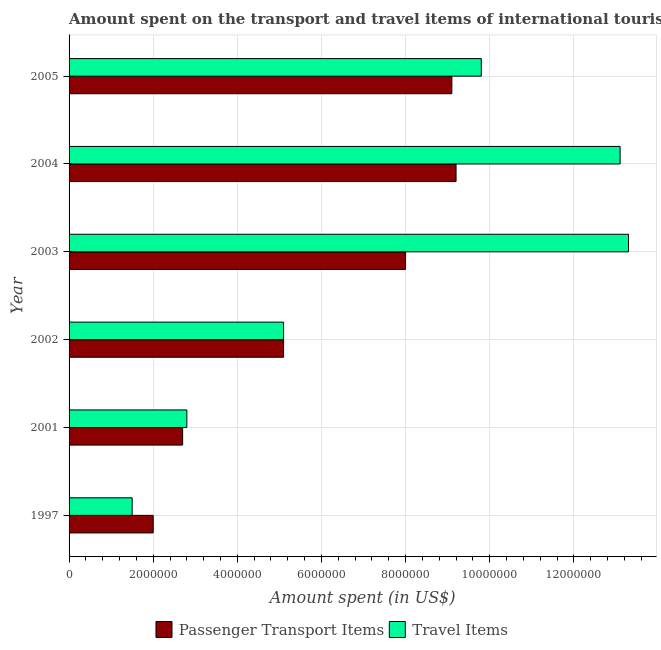How many different coloured bars are there?
Keep it short and to the point. 2. Are the number of bars per tick equal to the number of legend labels?
Offer a very short reply. Yes. How many bars are there on the 4th tick from the top?
Offer a terse response. 2. How many bars are there on the 2nd tick from the bottom?
Your answer should be compact. 2. What is the amount spent in travel items in 2005?
Give a very brief answer. 9.80e+06. Across all years, what is the maximum amount spent in travel items?
Your response must be concise. 1.33e+07. Across all years, what is the minimum amount spent in travel items?
Keep it short and to the point. 1.50e+06. In which year was the amount spent in travel items maximum?
Offer a very short reply. 2003. In which year was the amount spent in travel items minimum?
Your answer should be very brief. 1997. What is the total amount spent in travel items in the graph?
Keep it short and to the point. 4.56e+07. What is the difference between the amount spent in travel items in 1997 and that in 2003?
Provide a short and direct response. -1.18e+07. What is the difference between the amount spent on passenger transport items in 2004 and the amount spent in travel items in 2002?
Offer a very short reply. 4.10e+06. What is the average amount spent in travel items per year?
Your answer should be compact. 7.60e+06. In the year 2004, what is the difference between the amount spent on passenger transport items and amount spent in travel items?
Your answer should be compact. -3.90e+06. In how many years, is the amount spent on passenger transport items greater than 5200000 US$?
Make the answer very short. 3. What is the ratio of the amount spent in travel items in 2001 to that in 2004?
Your answer should be very brief. 0.21. Is the difference between the amount spent on passenger transport items in 2002 and 2003 greater than the difference between the amount spent in travel items in 2002 and 2003?
Your response must be concise. Yes. What is the difference between the highest and the lowest amount spent on passenger transport items?
Give a very brief answer. 7.20e+06. What does the 2nd bar from the top in 2003 represents?
Give a very brief answer. Passenger Transport Items. What does the 2nd bar from the bottom in 1997 represents?
Keep it short and to the point. Travel Items. How many years are there in the graph?
Offer a very short reply. 6. What is the difference between two consecutive major ticks on the X-axis?
Your answer should be compact. 2.00e+06. Are the values on the major ticks of X-axis written in scientific E-notation?
Your answer should be very brief. No. Does the graph contain grids?
Your answer should be very brief. Yes. Where does the legend appear in the graph?
Ensure brevity in your answer.  Bottom center. What is the title of the graph?
Offer a very short reply. Amount spent on the transport and travel items of international tourists visited in Guinea-Bissau. Does "Frequency of shipment arrival" appear as one of the legend labels in the graph?
Provide a short and direct response. No. What is the label or title of the X-axis?
Your answer should be very brief. Amount spent (in US$). What is the label or title of the Y-axis?
Give a very brief answer. Year. What is the Amount spent (in US$) of Passenger Transport Items in 1997?
Provide a succinct answer. 2.00e+06. What is the Amount spent (in US$) in Travel Items in 1997?
Provide a short and direct response. 1.50e+06. What is the Amount spent (in US$) in Passenger Transport Items in 2001?
Your answer should be very brief. 2.70e+06. What is the Amount spent (in US$) of Travel Items in 2001?
Keep it short and to the point. 2.80e+06. What is the Amount spent (in US$) in Passenger Transport Items in 2002?
Offer a very short reply. 5.10e+06. What is the Amount spent (in US$) of Travel Items in 2002?
Your answer should be compact. 5.10e+06. What is the Amount spent (in US$) in Travel Items in 2003?
Ensure brevity in your answer.  1.33e+07. What is the Amount spent (in US$) in Passenger Transport Items in 2004?
Offer a terse response. 9.20e+06. What is the Amount spent (in US$) in Travel Items in 2004?
Ensure brevity in your answer.  1.31e+07. What is the Amount spent (in US$) in Passenger Transport Items in 2005?
Your answer should be compact. 9.10e+06. What is the Amount spent (in US$) of Travel Items in 2005?
Your answer should be compact. 9.80e+06. Across all years, what is the maximum Amount spent (in US$) in Passenger Transport Items?
Offer a terse response. 9.20e+06. Across all years, what is the maximum Amount spent (in US$) of Travel Items?
Provide a short and direct response. 1.33e+07. Across all years, what is the minimum Amount spent (in US$) of Passenger Transport Items?
Your answer should be very brief. 2.00e+06. Across all years, what is the minimum Amount spent (in US$) in Travel Items?
Your answer should be very brief. 1.50e+06. What is the total Amount spent (in US$) in Passenger Transport Items in the graph?
Offer a terse response. 3.61e+07. What is the total Amount spent (in US$) of Travel Items in the graph?
Give a very brief answer. 4.56e+07. What is the difference between the Amount spent (in US$) in Passenger Transport Items in 1997 and that in 2001?
Provide a succinct answer. -7.00e+05. What is the difference between the Amount spent (in US$) in Travel Items in 1997 and that in 2001?
Ensure brevity in your answer.  -1.30e+06. What is the difference between the Amount spent (in US$) in Passenger Transport Items in 1997 and that in 2002?
Ensure brevity in your answer.  -3.10e+06. What is the difference between the Amount spent (in US$) of Travel Items in 1997 and that in 2002?
Keep it short and to the point. -3.60e+06. What is the difference between the Amount spent (in US$) in Passenger Transport Items in 1997 and that in 2003?
Your answer should be very brief. -6.00e+06. What is the difference between the Amount spent (in US$) of Travel Items in 1997 and that in 2003?
Give a very brief answer. -1.18e+07. What is the difference between the Amount spent (in US$) in Passenger Transport Items in 1997 and that in 2004?
Make the answer very short. -7.20e+06. What is the difference between the Amount spent (in US$) in Travel Items in 1997 and that in 2004?
Offer a terse response. -1.16e+07. What is the difference between the Amount spent (in US$) in Passenger Transport Items in 1997 and that in 2005?
Offer a very short reply. -7.10e+06. What is the difference between the Amount spent (in US$) of Travel Items in 1997 and that in 2005?
Offer a terse response. -8.30e+06. What is the difference between the Amount spent (in US$) of Passenger Transport Items in 2001 and that in 2002?
Your response must be concise. -2.40e+06. What is the difference between the Amount spent (in US$) of Travel Items in 2001 and that in 2002?
Offer a terse response. -2.30e+06. What is the difference between the Amount spent (in US$) in Passenger Transport Items in 2001 and that in 2003?
Ensure brevity in your answer.  -5.30e+06. What is the difference between the Amount spent (in US$) in Travel Items in 2001 and that in 2003?
Ensure brevity in your answer.  -1.05e+07. What is the difference between the Amount spent (in US$) in Passenger Transport Items in 2001 and that in 2004?
Your answer should be very brief. -6.50e+06. What is the difference between the Amount spent (in US$) of Travel Items in 2001 and that in 2004?
Keep it short and to the point. -1.03e+07. What is the difference between the Amount spent (in US$) in Passenger Transport Items in 2001 and that in 2005?
Make the answer very short. -6.40e+06. What is the difference between the Amount spent (in US$) in Travel Items in 2001 and that in 2005?
Offer a terse response. -7.00e+06. What is the difference between the Amount spent (in US$) in Passenger Transport Items in 2002 and that in 2003?
Your answer should be compact. -2.90e+06. What is the difference between the Amount spent (in US$) of Travel Items in 2002 and that in 2003?
Your answer should be compact. -8.20e+06. What is the difference between the Amount spent (in US$) of Passenger Transport Items in 2002 and that in 2004?
Offer a terse response. -4.10e+06. What is the difference between the Amount spent (in US$) of Travel Items in 2002 and that in 2004?
Keep it short and to the point. -8.00e+06. What is the difference between the Amount spent (in US$) of Travel Items in 2002 and that in 2005?
Give a very brief answer. -4.70e+06. What is the difference between the Amount spent (in US$) in Passenger Transport Items in 2003 and that in 2004?
Provide a short and direct response. -1.20e+06. What is the difference between the Amount spent (in US$) of Passenger Transport Items in 2003 and that in 2005?
Your response must be concise. -1.10e+06. What is the difference between the Amount spent (in US$) in Travel Items in 2003 and that in 2005?
Your answer should be very brief. 3.50e+06. What is the difference between the Amount spent (in US$) in Travel Items in 2004 and that in 2005?
Provide a succinct answer. 3.30e+06. What is the difference between the Amount spent (in US$) in Passenger Transport Items in 1997 and the Amount spent (in US$) in Travel Items in 2001?
Your answer should be compact. -8.00e+05. What is the difference between the Amount spent (in US$) in Passenger Transport Items in 1997 and the Amount spent (in US$) in Travel Items in 2002?
Your answer should be very brief. -3.10e+06. What is the difference between the Amount spent (in US$) in Passenger Transport Items in 1997 and the Amount spent (in US$) in Travel Items in 2003?
Your response must be concise. -1.13e+07. What is the difference between the Amount spent (in US$) of Passenger Transport Items in 1997 and the Amount spent (in US$) of Travel Items in 2004?
Your answer should be very brief. -1.11e+07. What is the difference between the Amount spent (in US$) of Passenger Transport Items in 1997 and the Amount spent (in US$) of Travel Items in 2005?
Make the answer very short. -7.80e+06. What is the difference between the Amount spent (in US$) of Passenger Transport Items in 2001 and the Amount spent (in US$) of Travel Items in 2002?
Make the answer very short. -2.40e+06. What is the difference between the Amount spent (in US$) in Passenger Transport Items in 2001 and the Amount spent (in US$) in Travel Items in 2003?
Keep it short and to the point. -1.06e+07. What is the difference between the Amount spent (in US$) in Passenger Transport Items in 2001 and the Amount spent (in US$) in Travel Items in 2004?
Make the answer very short. -1.04e+07. What is the difference between the Amount spent (in US$) of Passenger Transport Items in 2001 and the Amount spent (in US$) of Travel Items in 2005?
Provide a succinct answer. -7.10e+06. What is the difference between the Amount spent (in US$) in Passenger Transport Items in 2002 and the Amount spent (in US$) in Travel Items in 2003?
Provide a short and direct response. -8.20e+06. What is the difference between the Amount spent (in US$) of Passenger Transport Items in 2002 and the Amount spent (in US$) of Travel Items in 2004?
Offer a terse response. -8.00e+06. What is the difference between the Amount spent (in US$) in Passenger Transport Items in 2002 and the Amount spent (in US$) in Travel Items in 2005?
Your response must be concise. -4.70e+06. What is the difference between the Amount spent (in US$) in Passenger Transport Items in 2003 and the Amount spent (in US$) in Travel Items in 2004?
Offer a terse response. -5.10e+06. What is the difference between the Amount spent (in US$) in Passenger Transport Items in 2003 and the Amount spent (in US$) in Travel Items in 2005?
Your answer should be compact. -1.80e+06. What is the difference between the Amount spent (in US$) of Passenger Transport Items in 2004 and the Amount spent (in US$) of Travel Items in 2005?
Provide a short and direct response. -6.00e+05. What is the average Amount spent (in US$) of Passenger Transport Items per year?
Keep it short and to the point. 6.02e+06. What is the average Amount spent (in US$) of Travel Items per year?
Provide a short and direct response. 7.60e+06. In the year 2001, what is the difference between the Amount spent (in US$) in Passenger Transport Items and Amount spent (in US$) in Travel Items?
Provide a short and direct response. -1.00e+05. In the year 2003, what is the difference between the Amount spent (in US$) of Passenger Transport Items and Amount spent (in US$) of Travel Items?
Make the answer very short. -5.30e+06. In the year 2004, what is the difference between the Amount spent (in US$) in Passenger Transport Items and Amount spent (in US$) in Travel Items?
Provide a short and direct response. -3.90e+06. In the year 2005, what is the difference between the Amount spent (in US$) in Passenger Transport Items and Amount spent (in US$) in Travel Items?
Provide a short and direct response. -7.00e+05. What is the ratio of the Amount spent (in US$) of Passenger Transport Items in 1997 to that in 2001?
Offer a very short reply. 0.74. What is the ratio of the Amount spent (in US$) of Travel Items in 1997 to that in 2001?
Give a very brief answer. 0.54. What is the ratio of the Amount spent (in US$) in Passenger Transport Items in 1997 to that in 2002?
Give a very brief answer. 0.39. What is the ratio of the Amount spent (in US$) in Travel Items in 1997 to that in 2002?
Your answer should be compact. 0.29. What is the ratio of the Amount spent (in US$) in Passenger Transport Items in 1997 to that in 2003?
Offer a very short reply. 0.25. What is the ratio of the Amount spent (in US$) in Travel Items in 1997 to that in 2003?
Your response must be concise. 0.11. What is the ratio of the Amount spent (in US$) of Passenger Transport Items in 1997 to that in 2004?
Your answer should be very brief. 0.22. What is the ratio of the Amount spent (in US$) of Travel Items in 1997 to that in 2004?
Your answer should be compact. 0.11. What is the ratio of the Amount spent (in US$) of Passenger Transport Items in 1997 to that in 2005?
Ensure brevity in your answer.  0.22. What is the ratio of the Amount spent (in US$) of Travel Items in 1997 to that in 2005?
Ensure brevity in your answer.  0.15. What is the ratio of the Amount spent (in US$) in Passenger Transport Items in 2001 to that in 2002?
Give a very brief answer. 0.53. What is the ratio of the Amount spent (in US$) of Travel Items in 2001 to that in 2002?
Your answer should be very brief. 0.55. What is the ratio of the Amount spent (in US$) in Passenger Transport Items in 2001 to that in 2003?
Provide a succinct answer. 0.34. What is the ratio of the Amount spent (in US$) in Travel Items in 2001 to that in 2003?
Offer a terse response. 0.21. What is the ratio of the Amount spent (in US$) of Passenger Transport Items in 2001 to that in 2004?
Your answer should be compact. 0.29. What is the ratio of the Amount spent (in US$) of Travel Items in 2001 to that in 2004?
Offer a very short reply. 0.21. What is the ratio of the Amount spent (in US$) of Passenger Transport Items in 2001 to that in 2005?
Provide a short and direct response. 0.3. What is the ratio of the Amount spent (in US$) in Travel Items in 2001 to that in 2005?
Provide a short and direct response. 0.29. What is the ratio of the Amount spent (in US$) of Passenger Transport Items in 2002 to that in 2003?
Make the answer very short. 0.64. What is the ratio of the Amount spent (in US$) in Travel Items in 2002 to that in 2003?
Offer a terse response. 0.38. What is the ratio of the Amount spent (in US$) of Passenger Transport Items in 2002 to that in 2004?
Provide a succinct answer. 0.55. What is the ratio of the Amount spent (in US$) of Travel Items in 2002 to that in 2004?
Give a very brief answer. 0.39. What is the ratio of the Amount spent (in US$) of Passenger Transport Items in 2002 to that in 2005?
Your answer should be very brief. 0.56. What is the ratio of the Amount spent (in US$) in Travel Items in 2002 to that in 2005?
Ensure brevity in your answer.  0.52. What is the ratio of the Amount spent (in US$) in Passenger Transport Items in 2003 to that in 2004?
Provide a short and direct response. 0.87. What is the ratio of the Amount spent (in US$) in Travel Items in 2003 to that in 2004?
Give a very brief answer. 1.02. What is the ratio of the Amount spent (in US$) in Passenger Transport Items in 2003 to that in 2005?
Provide a succinct answer. 0.88. What is the ratio of the Amount spent (in US$) of Travel Items in 2003 to that in 2005?
Your answer should be compact. 1.36. What is the ratio of the Amount spent (in US$) in Passenger Transport Items in 2004 to that in 2005?
Provide a short and direct response. 1.01. What is the ratio of the Amount spent (in US$) of Travel Items in 2004 to that in 2005?
Your answer should be very brief. 1.34. What is the difference between the highest and the second highest Amount spent (in US$) in Passenger Transport Items?
Your response must be concise. 1.00e+05. What is the difference between the highest and the second highest Amount spent (in US$) in Travel Items?
Make the answer very short. 2.00e+05. What is the difference between the highest and the lowest Amount spent (in US$) of Passenger Transport Items?
Ensure brevity in your answer.  7.20e+06. What is the difference between the highest and the lowest Amount spent (in US$) in Travel Items?
Provide a succinct answer. 1.18e+07. 